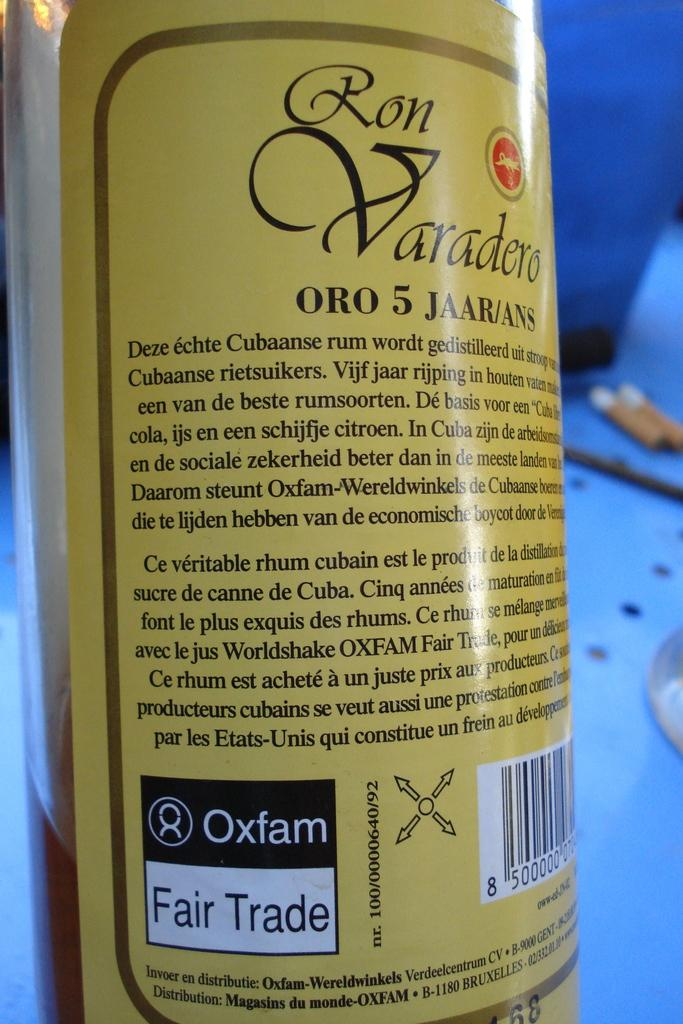<image>
Summarize the visual content of the image. A bottle of rum labeled Ron Varadero Oro 5 Jaar/Ans. 